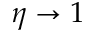<formula> <loc_0><loc_0><loc_500><loc_500>\eta \rightarrow 1</formula> 